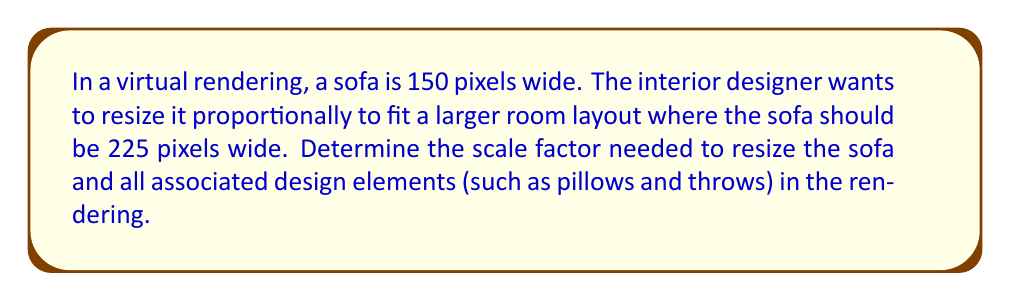Could you help me with this problem? To determine the scale factor, we need to use the concept of proportional relationships. The scale factor is the ratio of the new size to the original size.

Let's define our variables:
$x$ = original width
$y$ = new width
$s$ = scale factor

We know that:
$x = 150$ pixels (original width)
$y = 225$ pixels (new width)

The scale factor is given by the equation:

$$ s = \frac{y}{x} $$

Substituting our known values:

$$ s = \frac{225}{150} $$

To simplify this fraction, we can divide both the numerator and denominator by their greatest common factor (GCF). The GCF of 225 and 150 is 75.

$$ s = \frac{225 \div 75}{150 \div 75} = \frac{3}{2} = 1.5 $$

Therefore, the scale factor is 1.5 or 3/2.

This means that all design elements in the rendering should be multiplied by 1.5 to maintain the correct proportions in the resized layout.
Answer: 1.5 